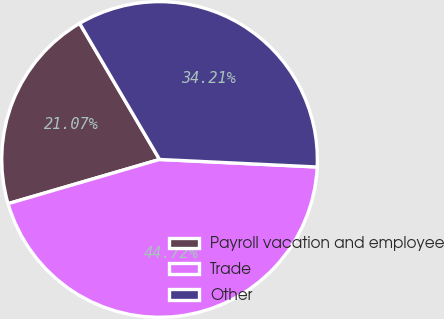<chart> <loc_0><loc_0><loc_500><loc_500><pie_chart><fcel>Payroll vacation and employee<fcel>Trade<fcel>Other<nl><fcel>21.07%<fcel>44.72%<fcel>34.21%<nl></chart> 